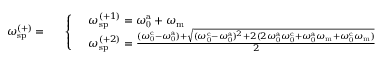<formula> <loc_0><loc_0><loc_500><loc_500>\omega _ { s p } ^ { ( + ) } = \begin{array} { r l } & { \left \{ \begin{array} { l l } & { \omega _ { s p } ^ { ( + 1 ) } = \omega _ { 0 } ^ { a } + \omega _ { m } } \\ & { \omega _ { s p } ^ { ( + 2 ) } = \frac { ( \omega _ { 0 } ^ { c } - \omega _ { 0 } ^ { a } ) + \sqrt { ( \omega _ { 0 } ^ { c } - \omega _ { 0 } ^ { a } ) ^ { 2 } + 2 ( 2 \omega _ { 0 } ^ { a } \omega _ { 0 } ^ { c } + \omega _ { 0 } ^ { a } \omega _ { m } + \omega _ { 0 } ^ { c } \omega _ { m } ) } } { 2 } } \end{array} } \end{array}</formula> 